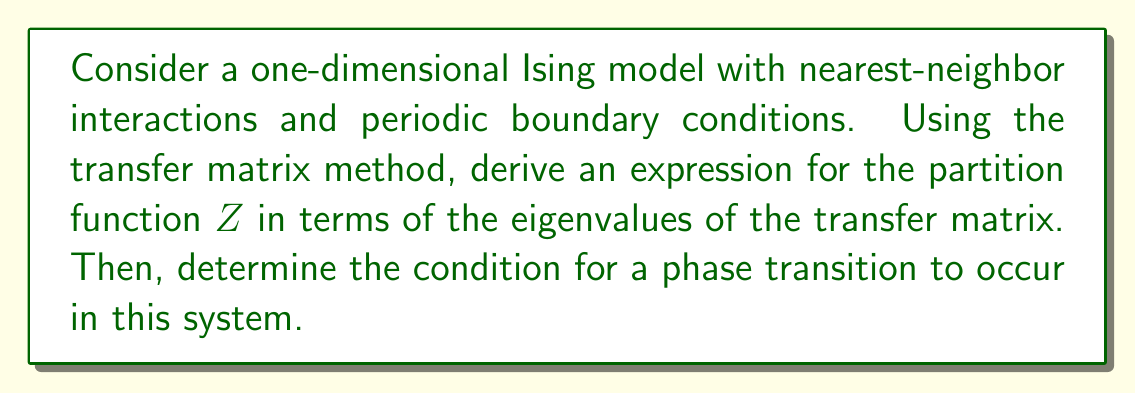Give your solution to this math problem. 1) First, we write the Hamiltonian for the 1D Ising model:

   $$H = -J\sum_{i=1}^N s_i s_{i+1} - h\sum_{i=1}^N s_i$$

   where $J$ is the coupling constant, $h$ is the external field, and $s_i = \pm 1$.

2) The partition function is given by:

   $$Z = \sum_{\{s_i\}} e^{-\beta H}$$

3) We can rewrite this as a product of transfer matrices:

   $$Z = \text{Tr}(T^N)$$

   where $T$ is the transfer matrix:

   $$T = \begin{pmatrix}
   e^{\beta(J+h)} & e^{-\beta J} \\
   e^{-\beta J} & e^{\beta(J-h)}
   \end{pmatrix}$$

4) The trace of $T^N$ can be expressed in terms of its eigenvalues:

   $$Z = \lambda_1^N + \lambda_2^N$$

   where $\lambda_1$ and $\lambda_2$ are the eigenvalues of $T$.

5) The eigenvalues are given by:

   $$\lambda_{1,2} = e^{\beta J} \cosh(\beta h) \pm \sqrt{e^{2\beta J} \sinh^2(\beta h) + e^{-2\beta J}}$$

6) In the thermodynamic limit ($N \to \infty$), the free energy per site is:

   $$f = -\frac{1}{\beta} \lim_{N \to \infty} \frac{1}{N} \ln Z = -\frac{1}{\beta} \ln \lambda_1$$

   where $\lambda_1$ is the larger eigenvalue.

7) A phase transition occurs when there's a non-analyticity in the free energy. This happens only if the largest eigenvalue becomes degenerate with the second eigenvalue.

8) For the 1D Ising model, $\lambda_1 > \lambda_2$ for all finite temperatures. The eigenvalues become equal only at $T = 0$ ($\beta \to \infty$).

Therefore, there is no phase transition at any finite temperature in the 1D Ising model.
Answer: No phase transition occurs at finite temperature in the 1D Ising model. 